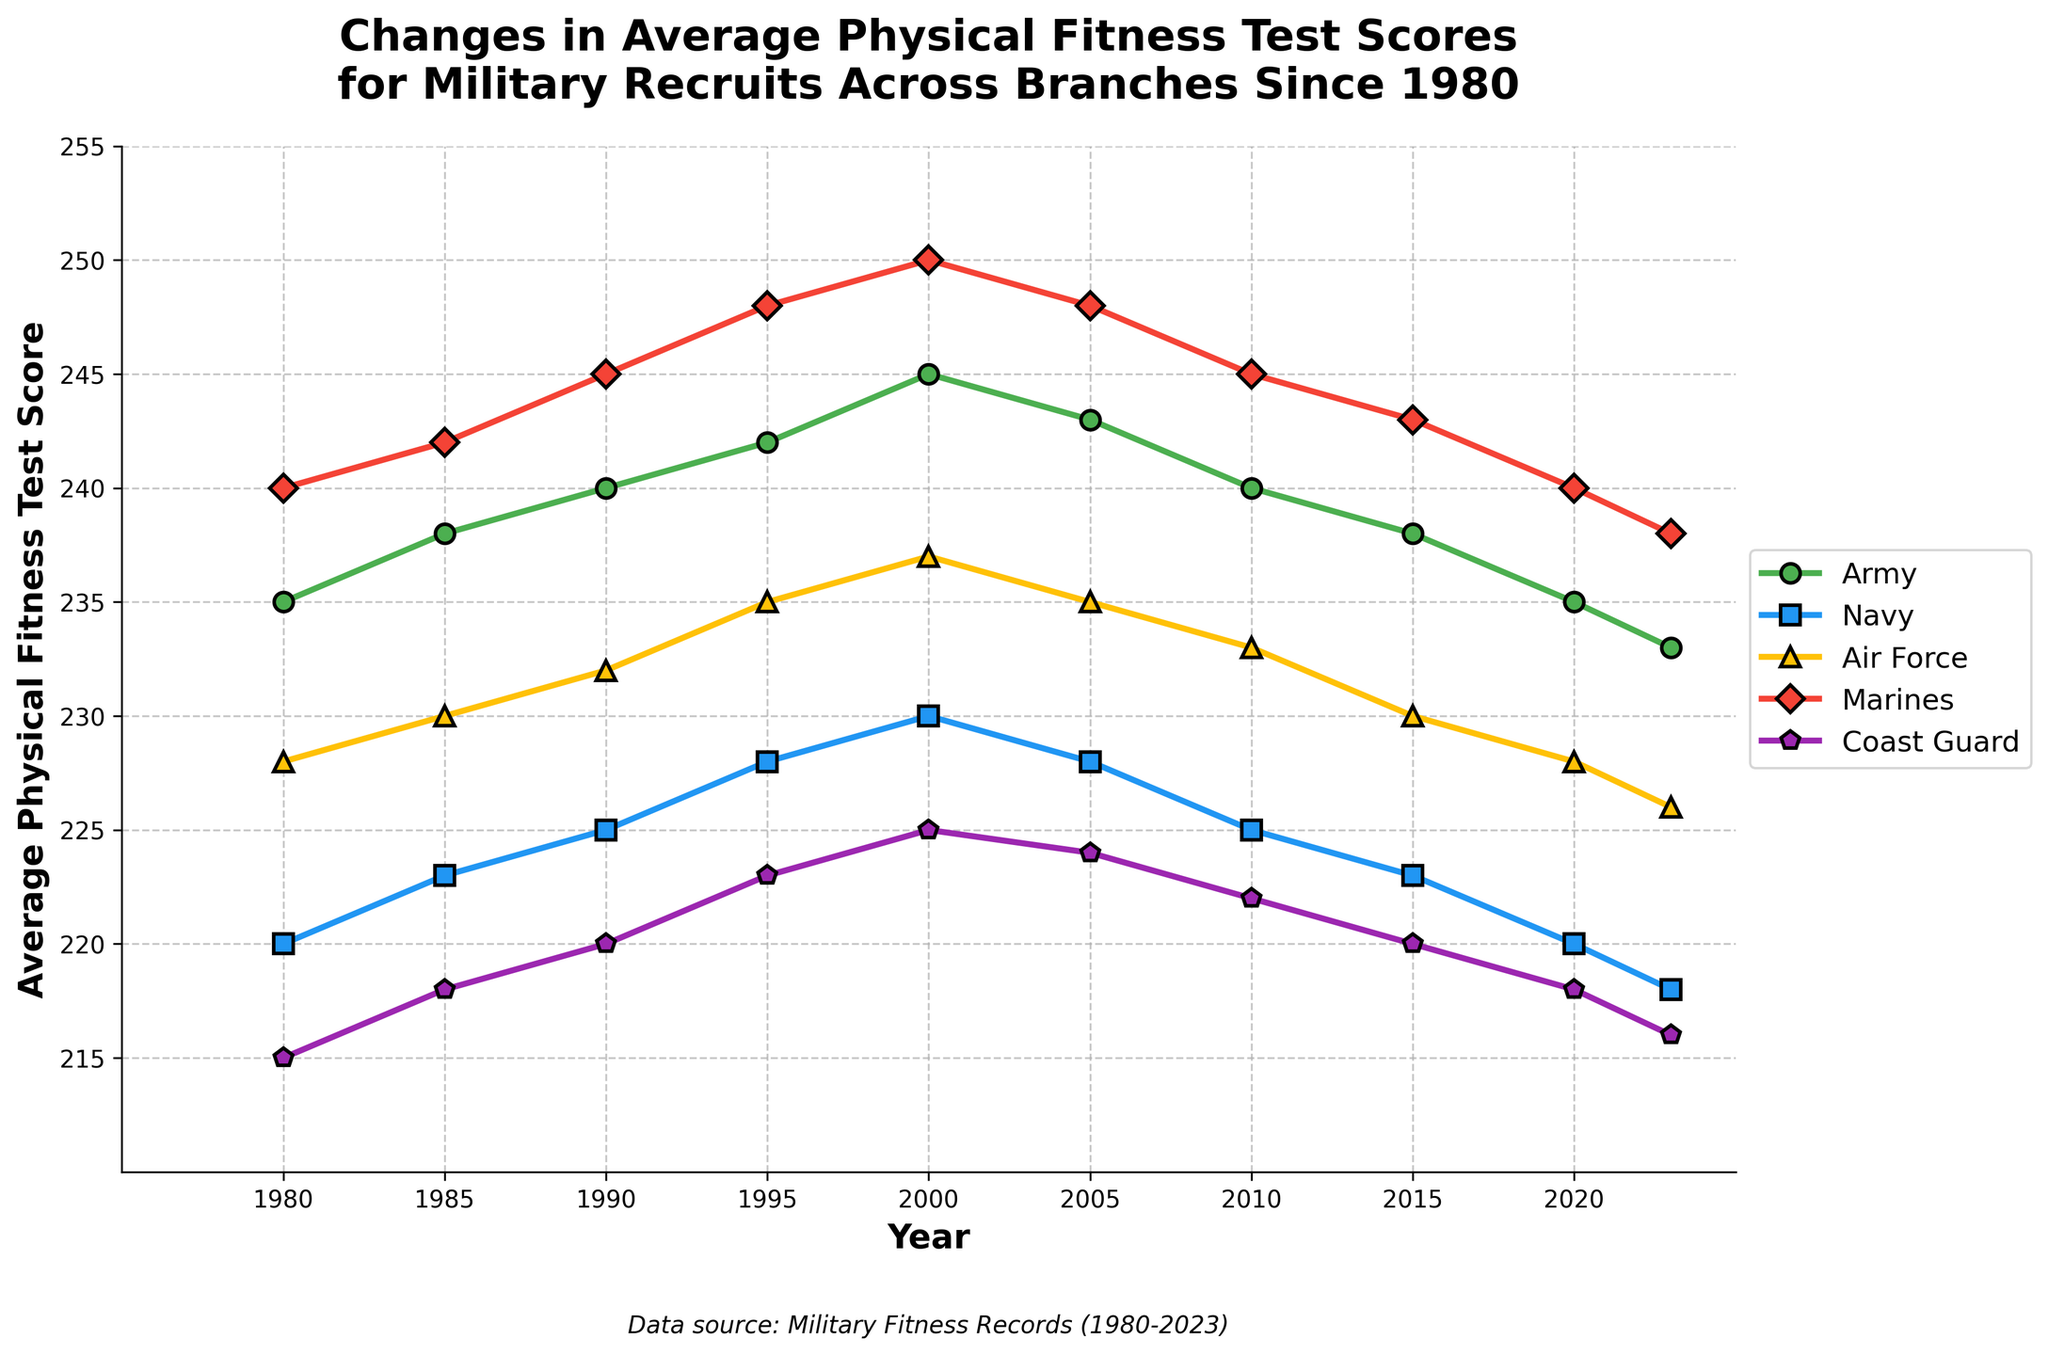What's the trend of the average physical fitness test scores for the Army? By looking at the line for the Army from 1980 to 2023, we see a rise from 235 to a peak of 245 around 2000, followed by a gradual decline to 233 in 2023.
Answer: Rising until 2000, then declining Which branch had the highest average physical fitness test score in 2023? To determine the highest score for 2023, we compare the data points for each branch. The Marines had the highest score at 238.
Answer: Marines How did the Navy's average physical fitness test score change from 1980 to 2023? The Navy's score began at 220 in 1980, rising to a peak of 230 in 2000, and then decreasing to 218 by 2023.
Answer: Increased, then decreased During which year did the Coast Guard reach its peak average physical fitness test score and what was that score? By looking at the Coast Guard's line, we see it peaked in 2000 with a score of 225.
Answer: 2000, 225 What is the average of the Marines' scores in 1980 and 2023? The Marines' scores for 1980 and 2023 are 240 and 238, respectively. The average of these two is (240 + 238) / 2 = 239.
Answer: 239 Which branch showed the most consistent trend in scores from 1980 to 2023, and how can you tell? The Coast Guard showed the most consistent trend, as their scores had minimal fluctuation with only a slight peak in 2000. The changes are very steady compared to other branches.
Answer: Coast Guard In what year were the Army and Marines' average fitness scores equal? Checking the lines for Army and Marines, we find they have equal scores of 248 in 1995.
Answer: 1995 Compare the changes in average fitness scores for the Air Force and the Navy between 2000 and 2023. Which branch had a greater decrease? The Navy's score dropped from 230 to 218, a decrease of 12 points. The Air Force's score decreased from 237 to 226, a decrease of 11 points. The Navy had a greater decrease.
Answer: Navy What's the overall trend for the Coast Guard's average physical fitness test scores from 1980 to 2023? Observing the Coast Guard's line, we see a gradual increase from 215 in 1980 to 225 in 2000, followed by a gradual decrease back to 216 in 2023, forming a peak around 2000.
Answer: Increase then decrease What is the difference between the highest and lowest scores for the Marines during the period shown? The highest score for the Marines is 250 in 2000, and the lowest is 238 in 2023. The difference is 250 - 238 = 12.
Answer: 12 